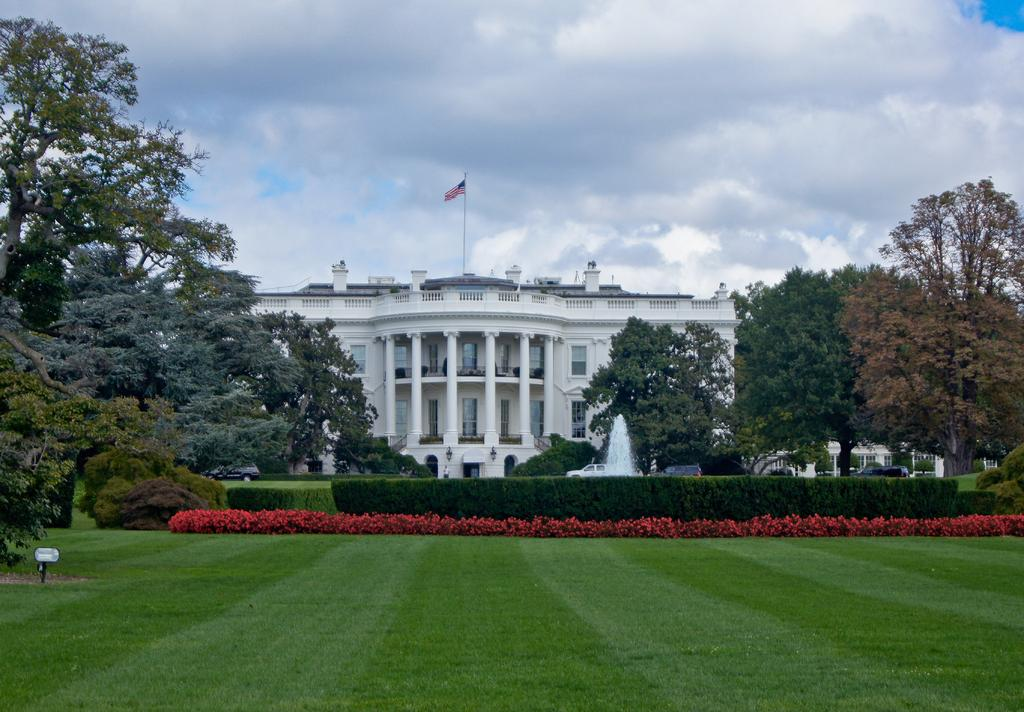What type of structure can be seen in the image? There is a building in the image. What is attached to the flag post? There is a flag in the image. What type of vegetation is present in the image? There are trees and bushes in the image. What part of the ground can be seen in the image? The ground is visible in the image. What type of flora is present in the image? There are flowers in the image. What type of water feature is present in the image? There is a fountain in the image. What type of transportation is present on the road in the image? Motor vehicles are present on the road in the image. What is visible in the sky in the image? The sky is visible in the image, and there are clouds in the sky. What does the man in the image believe about the effect of climate change on the environment? There is no man present in the image, and therefore no beliefs or opinions about climate change can be determined. 